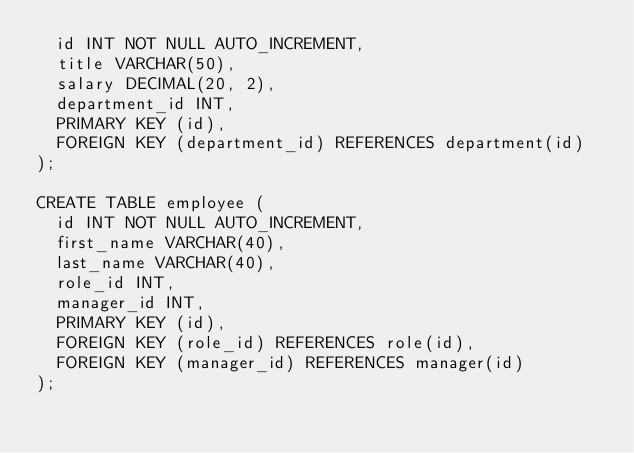Convert code to text. <code><loc_0><loc_0><loc_500><loc_500><_SQL_>  id INT NOT NULL AUTO_INCREMENT, 
  title VARCHAR(50), 
  salary DECIMAL(20, 2), 
  department_id INT,
  PRIMARY KEY (id), 
  FOREIGN KEY (department_id) REFERENCES department(id)
);

CREATE TABLE employee (
  id INT NOT NULL AUTO_INCREMENT,
  first_name VARCHAR(40),
  last_name VARCHAR(40),
  role_id INT,
  manager_id INT,
  PRIMARY KEY (id), 
  FOREIGN KEY (role_id) REFERENCES role(id),
  FOREIGN KEY (manager_id) REFERENCES manager(id)
); </code> 